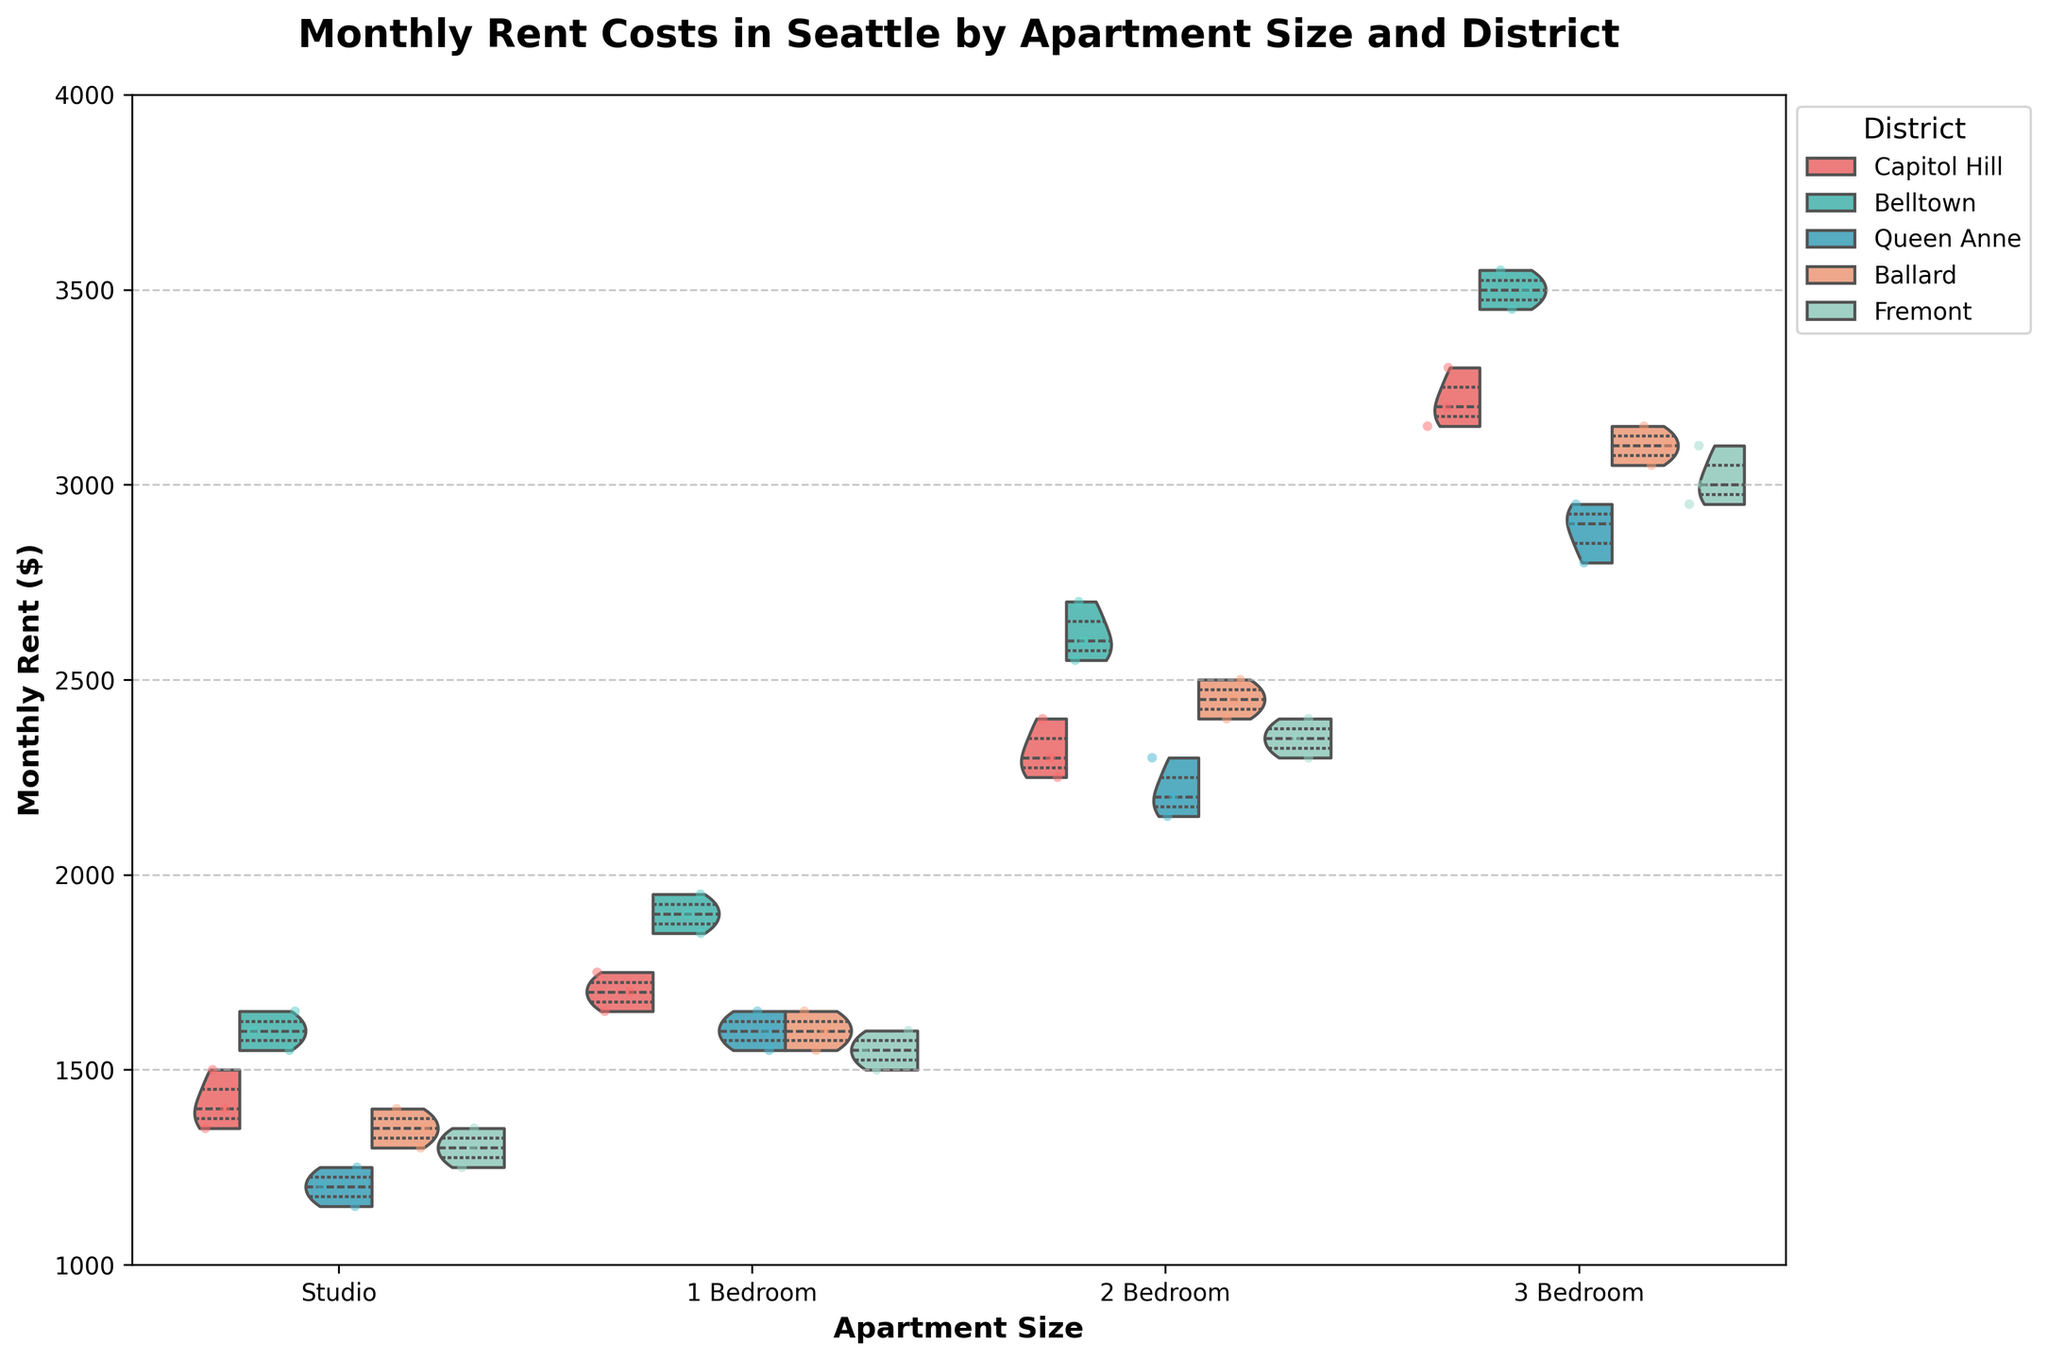What is the title of the plot? The title of the plot is usually bolded and larger than other text on the figure. Here, the title is placed above the plot area.
Answer: Monthly Rent Costs in Seattle by Apartment Size and District How many districts are represented in the plot? To determine the number of districts, look at the legend on the right side of the plot, where different colors represent different districts.
Answer: 5 Which district appears to have the highest median rent for 3 Bedroom apartments? To find the district with the highest median rent, look at the thickest part of the violin plot for the 3 Bedroom category and compare between districts.
Answer: Belltown What is the range of monthly rent for 1 Bedroom apartments in Queen Anne? To find this, look at the spread of the jittered points and the thickness of the violin plot in the 1 Bedroom category specifically for Queen Anne. The range is the difference between the highest and lowest rents.
Answer: $1,550 - $1,650 How do the rents of Studio apartments in Ballard compare to those in Fremont? Compare the positions of the dots and the shape of the violin plots for the Studio apartments of the two districts. Look for the central tendency and spread.
Answer: Ballard rents are generally higher What is the thickest part of a violin plot indicating? The thickest part of a violin plot indicates where the data points are most densely concentrated, effectively showing the mode or most frequent values in the dataset.
Answer: Most frequent values Are there any overlaps in median rents for 2 Bedroom apartments between different districts? Check the interquartile range (shown as a white bar in the middle of the violin) of the 2 Bedroom apartments in each district and see if they overlap.
Answer: Yes What's the range of the y-axis? The y-axis range can be seen on the left side of the plot, indicating the minimum and maximum rent values.
Answer: $1,000 to $4,000 Which Apartment Size has the most rent variability in Capitol Hill? To determine rent variability, look at the width of the violin plots and the spread of the jittered points for each apartment size in Capitol Hill. The wider and more spread out, the more variability.
Answer: 3 Bedroom Which district has the lowest median rent for Studio apartments? Examine the median values indicated by the center of the largest bulge in the violin plots for Studio apartments across all districts.
Answer: Queen Anne 